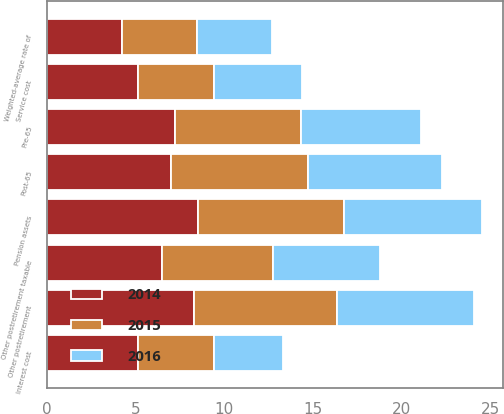Convert chart. <chart><loc_0><loc_0><loc_500><loc_500><stacked_bar_chart><ecel><fcel>Service cost<fcel>Interest cost<fcel>Weighted-average rate of<fcel>Pension assets<fcel>Other postretirement<fcel>Other postretirement taxable<fcel>Pre-65<fcel>Post-65<nl><fcel>2016<fcel>5<fcel>3.9<fcel>4.23<fcel>7.75<fcel>7.75<fcel>6<fcel>6.75<fcel>7.55<nl><fcel>2015<fcel>4.27<fcel>4.27<fcel>4.23<fcel>8.25<fcel>8.05<fcel>6.25<fcel>7.1<fcel>7.7<nl><fcel>2014<fcel>5.14<fcel>5.14<fcel>4.23<fcel>8.5<fcel>8.3<fcel>6.5<fcel>7.25<fcel>7<nl></chart> 